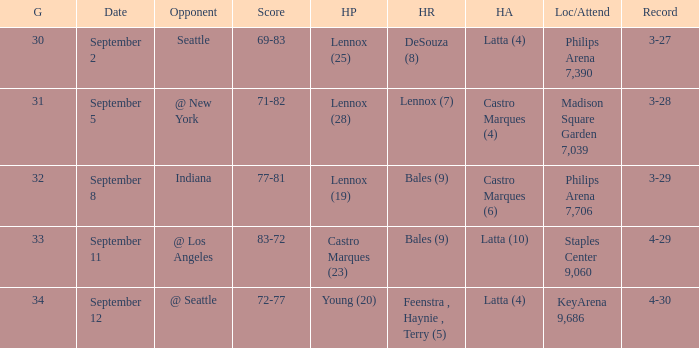What was the Location/Attendance on september 11? Staples Center 9,060. 